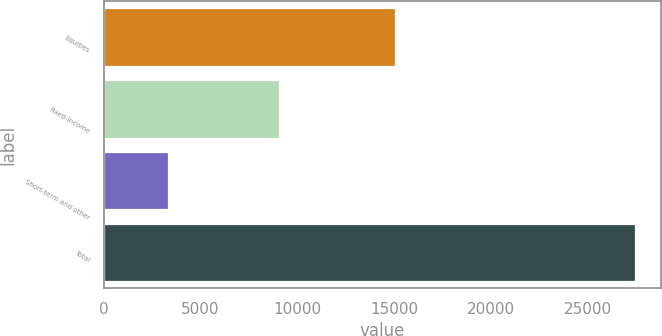Convert chart to OTSL. <chart><loc_0><loc_0><loc_500><loc_500><bar_chart><fcel>Equities<fcel>Fixed-income<fcel>Short-term and other<fcel>Total<nl><fcel>15050<fcel>9072<fcel>3305<fcel>27427<nl></chart> 